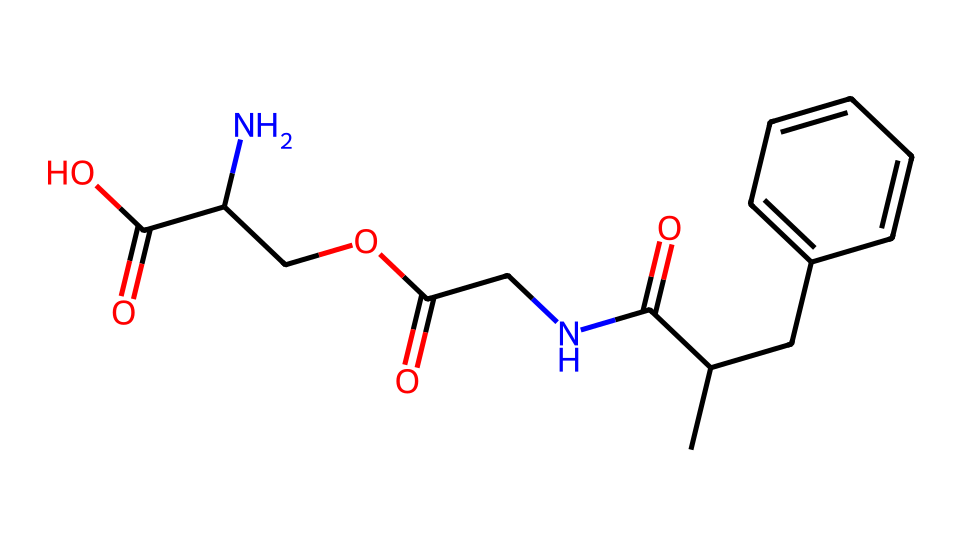What type of functional groups are present in this chemical? By analyzing the chemical structure, we can identify various functional groups such as carbonyl (C=O), amine (NH), and carboxylic acid (COOH). These groups can be identified by their distinct arrangements and bonding patterns in the structure.
Answer: carbonyl, amine, carboxylic acid How many carbon atoms are in the chemical? To find the number of carbon atoms, we can count the 'C' symbols present in the SMILES representation. Each 'C' represents a carbon atom, and careful counting reveals there are 12 carbon atoms in total in this structure.
Answer: 12 What is the overall charge of the molecule? By examining the components of the chemical, we see that it contains nitrogen and oxygen which can carry partial or full charges. However, since there are no explicit ions or charge notations in the structure, this molecule is neutral overall.
Answer: neutral Which functional group is responsible for its sweet taste? The presence of certain functional groups, such as carbonyl groups, can contribute to the sweetness of a compound, mainly through their interaction with taste receptors. In this case, the presence of amine and carbonyl groups indicates a possible sweet taste profile.
Answer: carbonyl What is the molecular formula derived from this SMILES representation? By analyzing the chemical composition from the SMILES notation, we can derive the molecular formula by counting the respective atoms of carbon, hydrogen, nitrogen, and oxygen. This results in the molecular formula C12H17N3O5.
Answer: C12H17N3O5 How many bonds are present in this molecule? To determine the total number of bonds, we can visualize the structural connections between atoms indicated in the SMILES. Counting all the covalent bonds formed between carbon, nitrogen, and oxygen gives us a total bond count of 19.
Answer: 19 